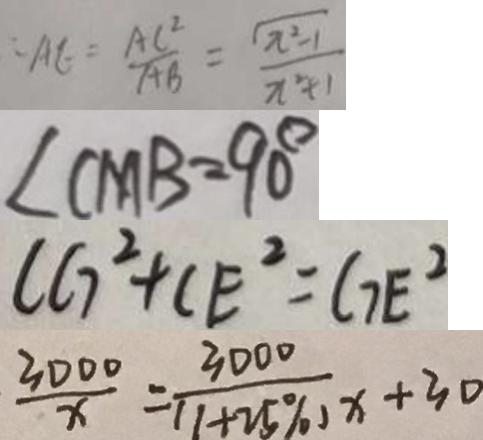<formula> <loc_0><loc_0><loc_500><loc_500>\therefore A E = \frac { A C ^ { 2 } } { A B } = \frac { \sqrt { x ^ { 2 } - 1 } } { x ^ { 2 } + 1 } 
 \angle C M B = 9 0 ^ { \circ } 
 C G ^ { 2 } + C E ^ { 2 } = G E ^ { 2 } 
 \frac { 3 0 0 0 } { x } = \frac { 3 0 0 0 } { ( 1 + 2 5 \% ) x } + 3 0</formula> 